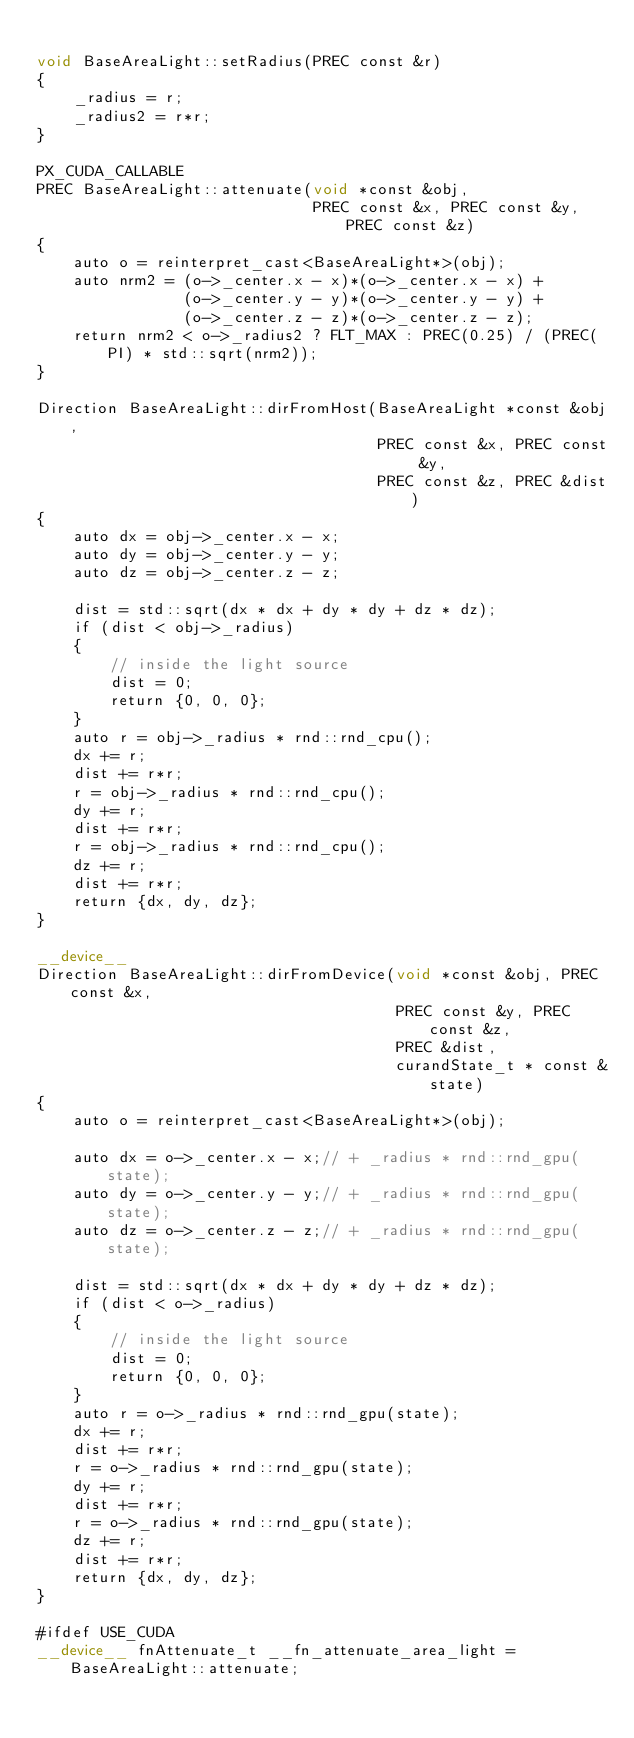Convert code to text. <code><loc_0><loc_0><loc_500><loc_500><_Cuda_>
void BaseAreaLight::setRadius(PREC const &r)
{
    _radius = r;
    _radius2 = r*r;
}

PX_CUDA_CALLABLE
PREC BaseAreaLight::attenuate(void *const &obj,
                              PREC const &x, PREC const &y, PREC const &z)
{
    auto o = reinterpret_cast<BaseAreaLight*>(obj);
    auto nrm2 = (o->_center.x - x)*(o->_center.x - x) +
                (o->_center.y - y)*(o->_center.y - y) +
                (o->_center.z - z)*(o->_center.z - z);
    return nrm2 < o->_radius2 ? FLT_MAX : PREC(0.25) / (PREC(PI) * std::sqrt(nrm2));
}

Direction BaseAreaLight::dirFromHost(BaseAreaLight *const &obj,
                                     PREC const &x, PREC const &y,
                                     PREC const &z, PREC &dist)
{
    auto dx = obj->_center.x - x;
    auto dy = obj->_center.y - y;
    auto dz = obj->_center.z - z;

    dist = std::sqrt(dx * dx + dy * dy + dz * dz);
    if (dist < obj->_radius)
    {
        // inside the light source
        dist = 0;
        return {0, 0, 0};
    }
    auto r = obj->_radius * rnd::rnd_cpu();
    dx += r;
    dist += r*r;
    r = obj->_radius * rnd::rnd_cpu();
    dy += r;
    dist += r*r;
    r = obj->_radius * rnd::rnd_cpu();
    dz += r;
    dist += r*r;
    return {dx, dy, dz};
}

__device__
Direction BaseAreaLight::dirFromDevice(void *const &obj, PREC const &x,
                                       PREC const &y, PREC const &z,
                                       PREC &dist,
                                       curandState_t * const &state)
{
    auto o = reinterpret_cast<BaseAreaLight*>(obj);

    auto dx = o->_center.x - x;// + _radius * rnd::rnd_gpu(state);
    auto dy = o->_center.y - y;// + _radius * rnd::rnd_gpu(state);
    auto dz = o->_center.z - z;// + _radius * rnd::rnd_gpu(state);

    dist = std::sqrt(dx * dx + dy * dy + dz * dz);
    if (dist < o->_radius)
    {
        // inside the light source
        dist = 0;
        return {0, 0, 0};
    }
    auto r = o->_radius * rnd::rnd_gpu(state);
    dx += r;
    dist += r*r;
    r = o->_radius * rnd::rnd_gpu(state);
    dy += r;
    dist += r*r;
    r = o->_radius * rnd::rnd_gpu(state);
    dz += r;
    dist += r*r;
    return {dx, dy, dz};
}

#ifdef USE_CUDA
__device__ fnAttenuate_t __fn_attenuate_area_light = BaseAreaLight::attenuate;</code> 